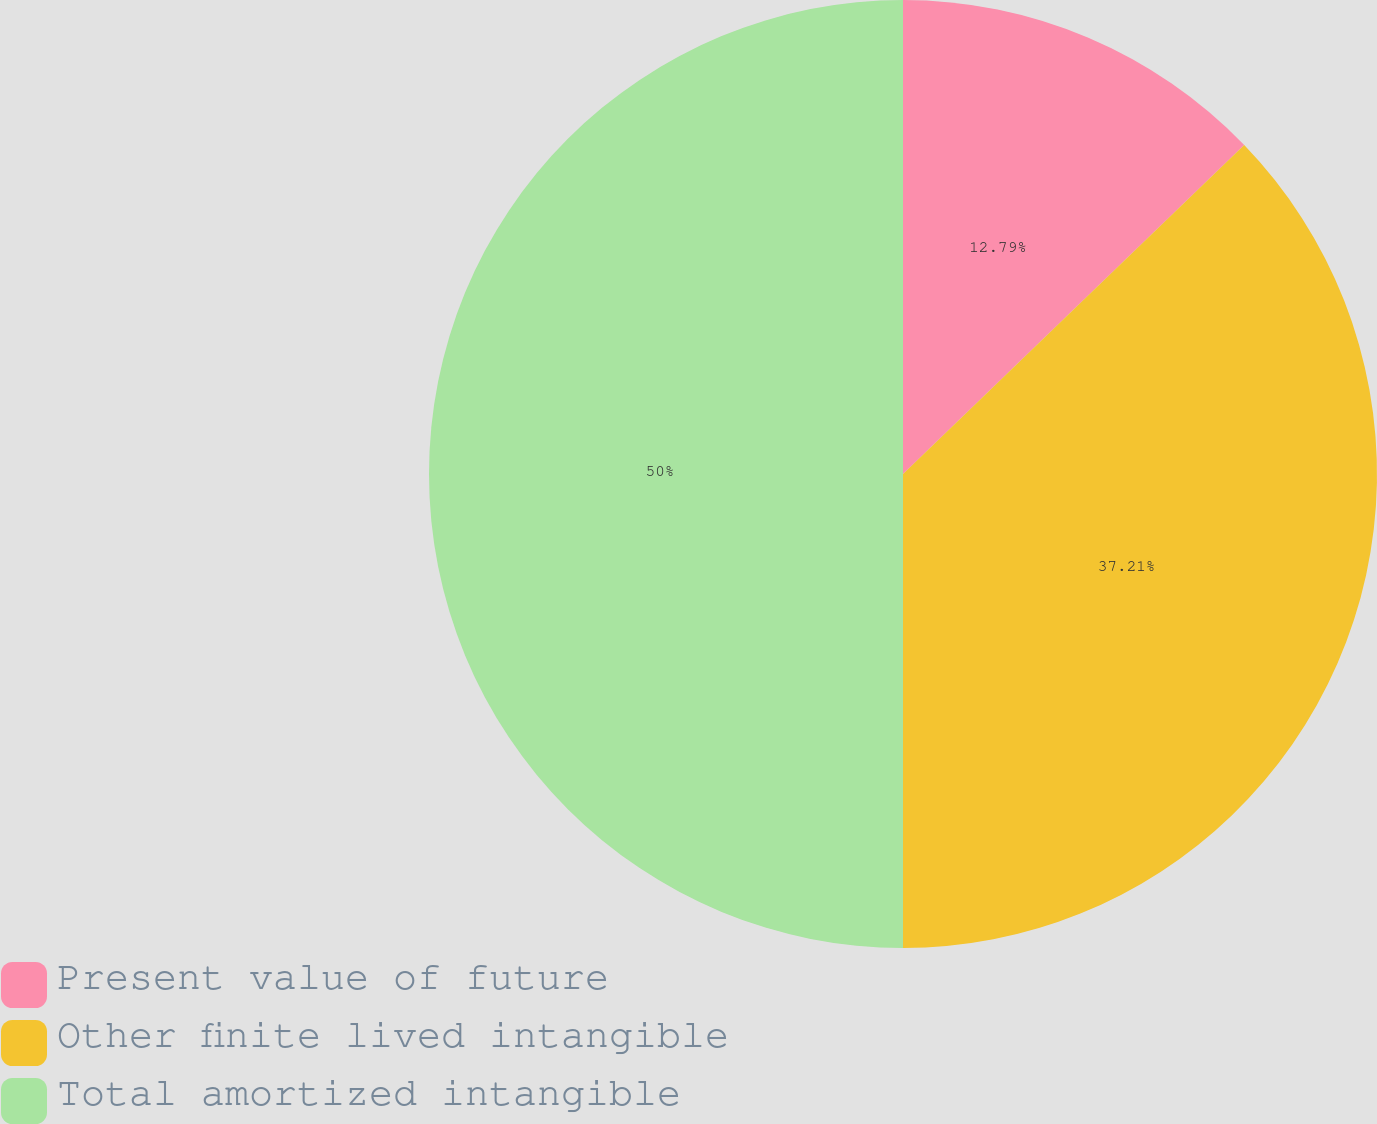Convert chart to OTSL. <chart><loc_0><loc_0><loc_500><loc_500><pie_chart><fcel>Present value of future<fcel>Other finite lived intangible<fcel>Total amortized intangible<nl><fcel>12.79%<fcel>37.21%<fcel>50.0%<nl></chart> 